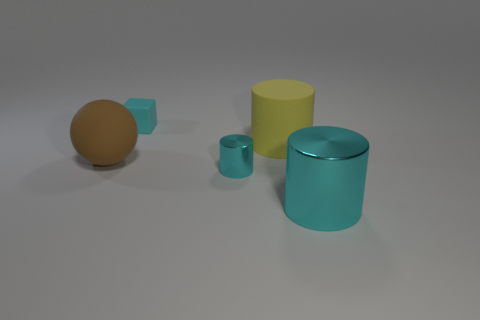The big brown object that is the same material as the yellow cylinder is what shape?
Provide a short and direct response. Sphere. There is a small cyan object on the left side of the tiny metal thing; does it have the same shape as the large cyan thing?
Your response must be concise. No. There is a small cyan thing that is in front of the brown ball; what is its shape?
Provide a succinct answer. Cylinder. There is a matte thing that is the same color as the large shiny object; what is its shape?
Give a very brief answer. Cube. What number of other brown balls have the same size as the brown matte ball?
Provide a short and direct response. 0. What color is the big rubber cylinder?
Provide a short and direct response. Yellow. There is a big rubber cylinder; is its color the same as the tiny thing behind the sphere?
Give a very brief answer. No. The cyan object that is the same material as the small cyan cylinder is what size?
Give a very brief answer. Large. Are there any big spheres of the same color as the rubber block?
Offer a terse response. No. How many things are either tiny things that are right of the small cyan matte cube or large yellow objects?
Keep it short and to the point. 2. 